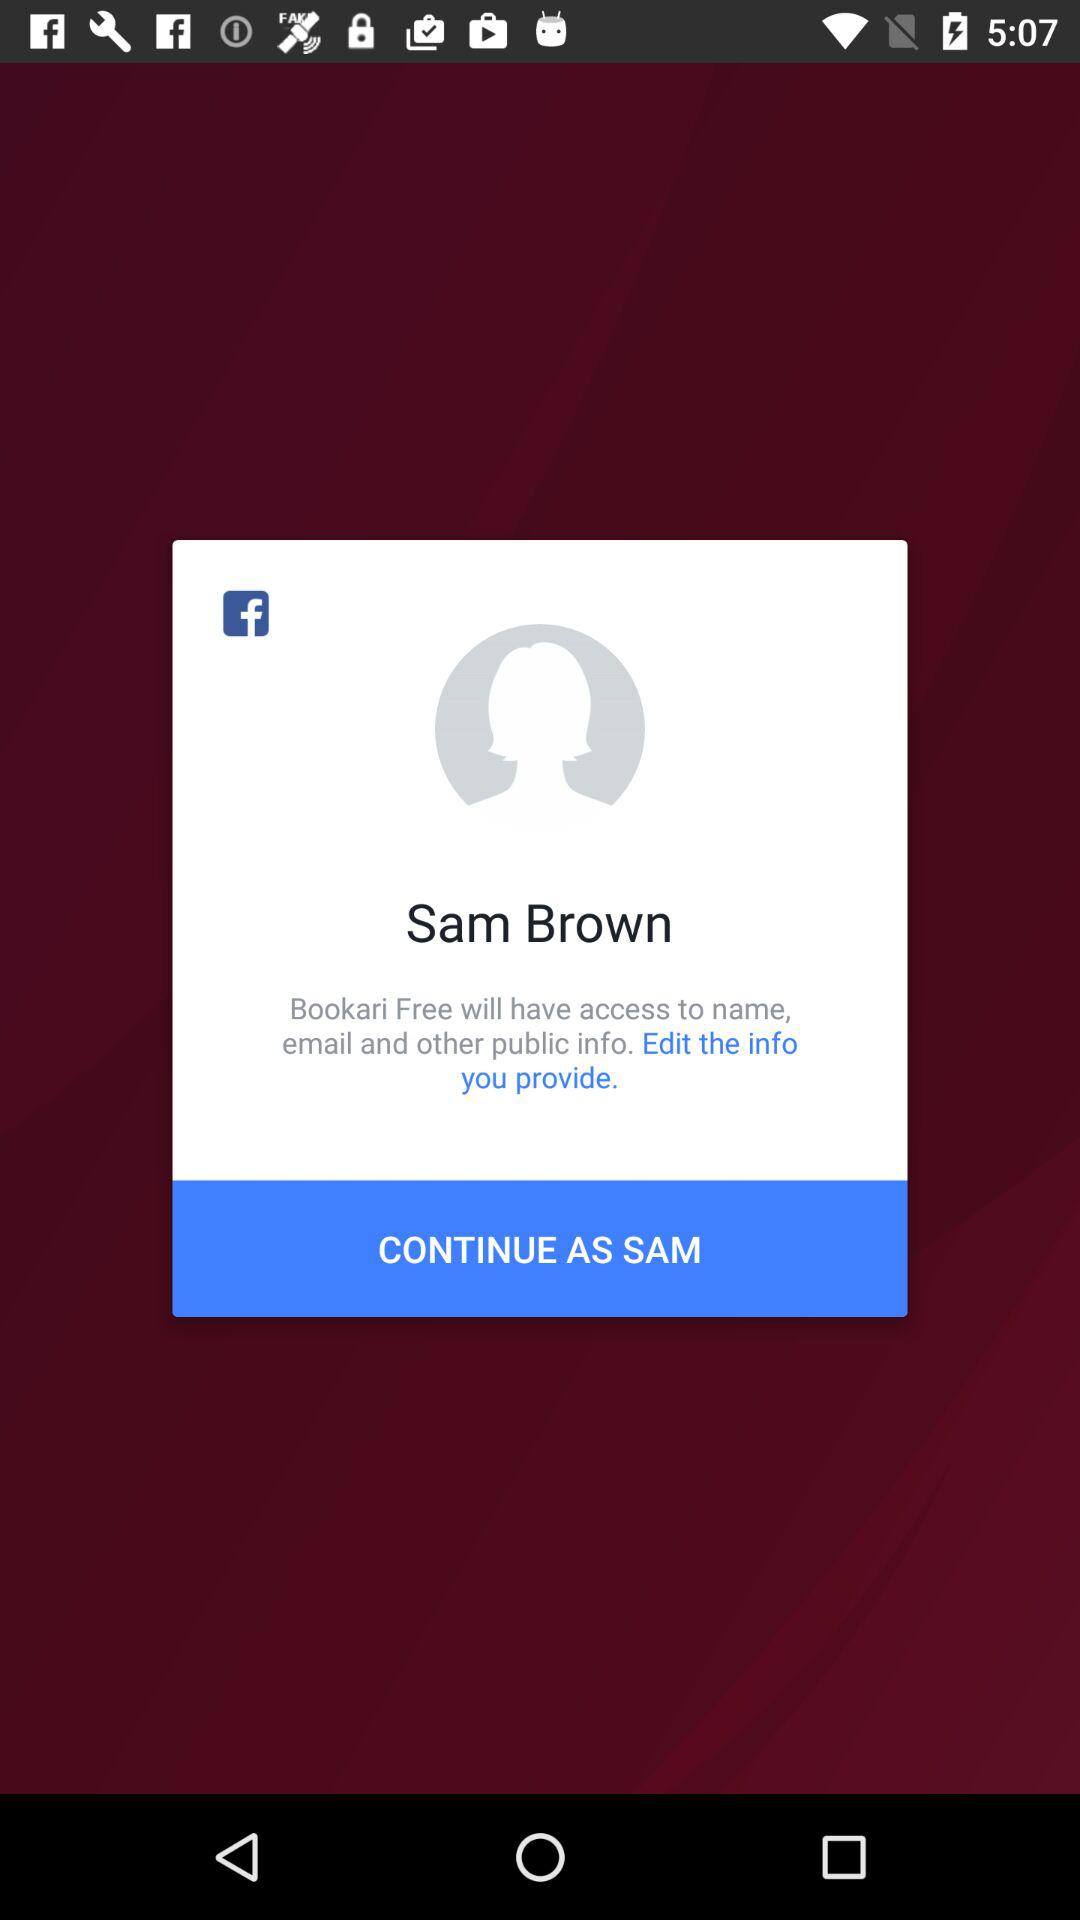What is the name of the user? The name of the user is Sam Brown. 